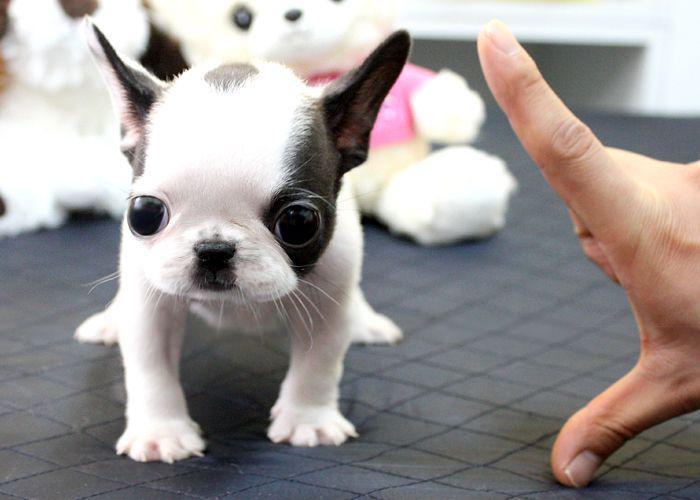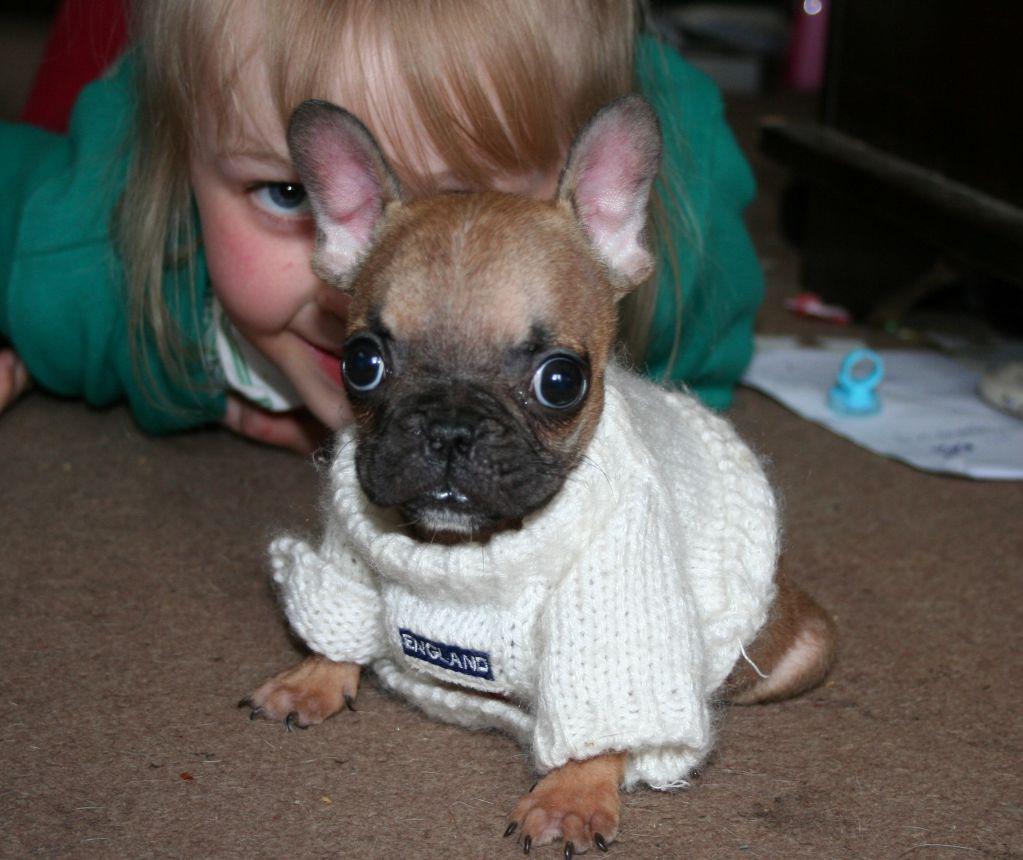The first image is the image on the left, the second image is the image on the right. Analyze the images presented: Is the assertion "The dog in the image on the right is standing on all fours." valid? Answer yes or no. No. The first image is the image on the left, the second image is the image on the right. For the images displayed, is the sentence "One image shows a sitting dog with pale coloring, and the other includes at least one tan dog with a dark muzzle who is wearing a collar." factually correct? Answer yes or no. No. 